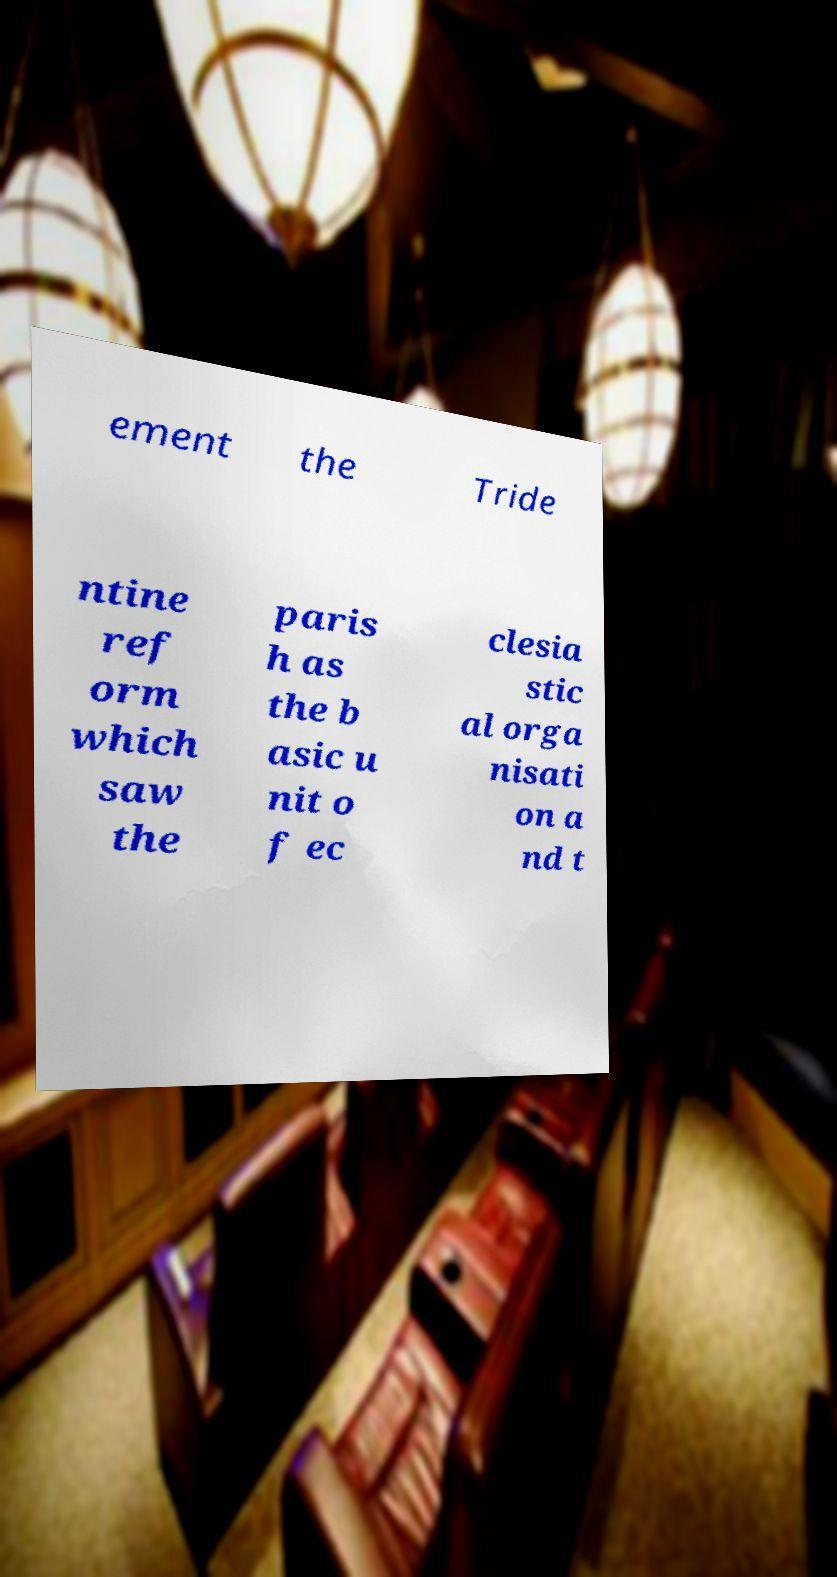Please read and relay the text visible in this image. What does it say? ement the Tride ntine ref orm which saw the paris h as the b asic u nit o f ec clesia stic al orga nisati on a nd t 